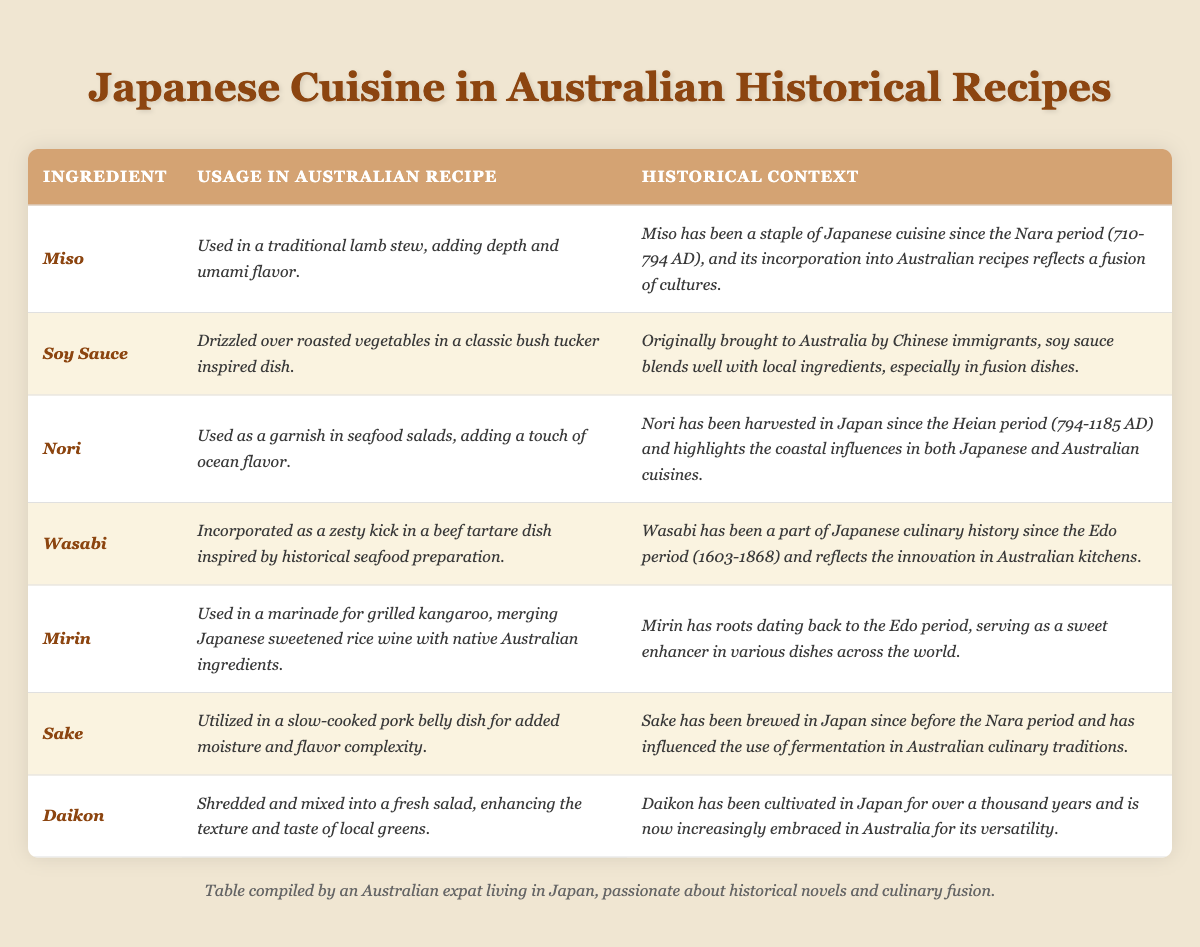What ingredient is used in a traditional lamb stew? According to the table, the ingredient used in a traditional lamb stew is *Miso*.
Answer: *Miso* Which Japanese ingredient is drizzled over roasted vegetables? The table specifies that *Soy Sauce* is drizzled over roasted vegetables.
Answer: *Soy Sauce* What historical period is associated with the harvesting of Nori? The table states that Nori has been harvested since the Heian period (794-1185 AD).
Answer: Heian period (794-1185 AD) How many ingredients from Japanese cuisine are used in Australian historical recipes? The table lists a total of 7 ingredients, which can be counted by inspecting the individual entries.
Answer: 7 Is Wasabi used in beef tartare? Yes, the table indicates that Wasabi is incorporated as a zesty kick in a beef tartare dish.
Answer: Yes Which ingredient is used as a marinade for grilled kangaroo? The table mentions that *Mirin* is used as a marinade for grilled kangaroo.
Answer: *Mirin* Which Japanese ingredient has been cultivated for over a thousand years? The table states that *Daikon* has been cultivated in Japan for over a thousand years.
Answer: *Daikon* What is the common historical context of Miso and Sake? Both Miso and Sake have roots dating back to the Nara period, emphasizing their long-standing significance in Japanese cuisine.
Answer: Nara period What ingredient adds ocean flavor to seafood salads? The table indicates that *Nori* is used as a garnish in seafood salads to add ocean flavor.
Answer: *Nori* Which ingredient is associated with a slow-cooked pork belly dish? According to the table, *Sake* is utilized in a slow-cooked pork belly dish for added moisture and flavor complexity.
Answer: *Sake* What is the oldest historical period mentioned for any ingredient's usage? The Edo period (1603-1868) for Wasabi is the oldest period mentioned, which is later than the Nara period (710-794 AD) also mentioned for Sake and Miso.
Answer: Edo period (1603-1868) Which ingredient combines Japanese flavor with native Australian ingredients? The table specifies that *Mirin* merges Japanese flavor with native Australian ingredients in a marinade for grilled kangaroo.
Answer: *Mirin* Between Miso and Daikon, which ingredient is mentioned as having a more direct impact on enhancing salad texture? The table indicates that *Daikon* is specifically mentioned as being shredded and mixed into a fresh salad for enhancing texture.
Answer: *Daikon* 